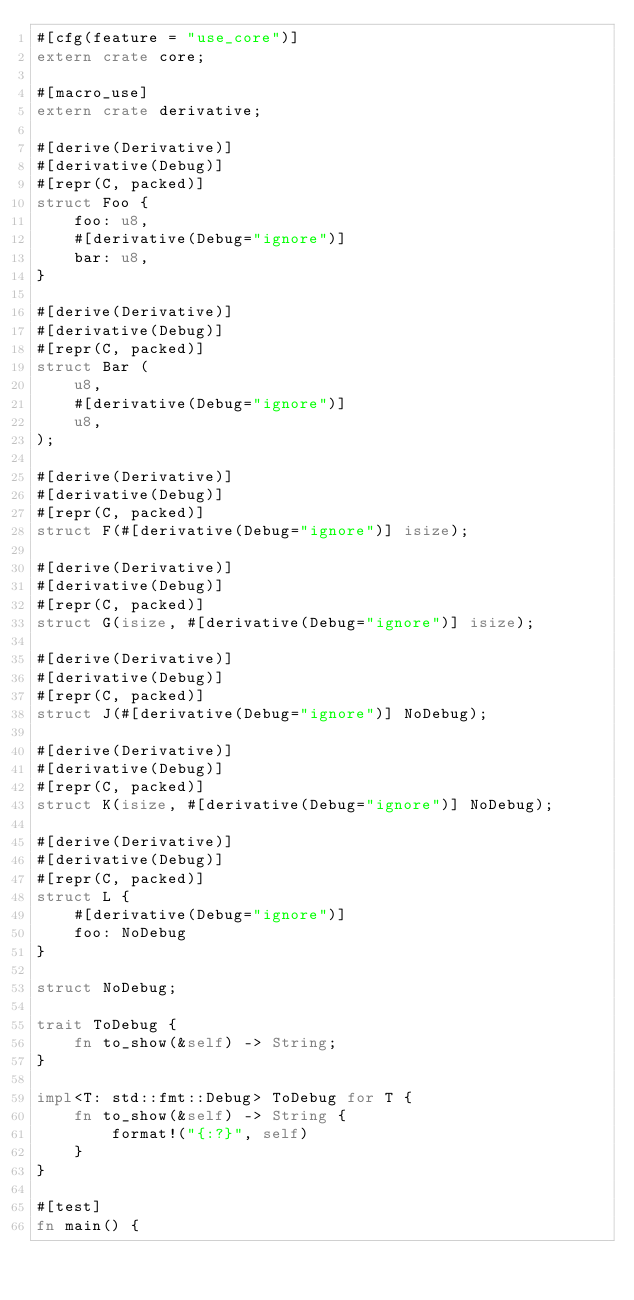Convert code to text. <code><loc_0><loc_0><loc_500><loc_500><_Rust_>#[cfg(feature = "use_core")]
extern crate core;

#[macro_use]
extern crate derivative;

#[derive(Derivative)]
#[derivative(Debug)]
#[repr(C, packed)]
struct Foo {
    foo: u8,
    #[derivative(Debug="ignore")]
    bar: u8,
}

#[derive(Derivative)]
#[derivative(Debug)]
#[repr(C, packed)]
struct Bar (
    u8,
    #[derivative(Debug="ignore")]
    u8,
);

#[derive(Derivative)]
#[derivative(Debug)]
#[repr(C, packed)]
struct F(#[derivative(Debug="ignore")] isize);

#[derive(Derivative)]
#[derivative(Debug)]
#[repr(C, packed)]
struct G(isize, #[derivative(Debug="ignore")] isize);

#[derive(Derivative)]
#[derivative(Debug)]
#[repr(C, packed)]
struct J(#[derivative(Debug="ignore")] NoDebug);

#[derive(Derivative)]
#[derivative(Debug)]
#[repr(C, packed)]
struct K(isize, #[derivative(Debug="ignore")] NoDebug);

#[derive(Derivative)]
#[derivative(Debug)]
#[repr(C, packed)]
struct L {
    #[derivative(Debug="ignore")]
    foo: NoDebug
}

struct NoDebug;

trait ToDebug {
    fn to_show(&self) -> String;
}

impl<T: std::fmt::Debug> ToDebug for T {
    fn to_show(&self) -> String {
        format!("{:?}", self)
    }
}

#[test]
fn main() {</code> 